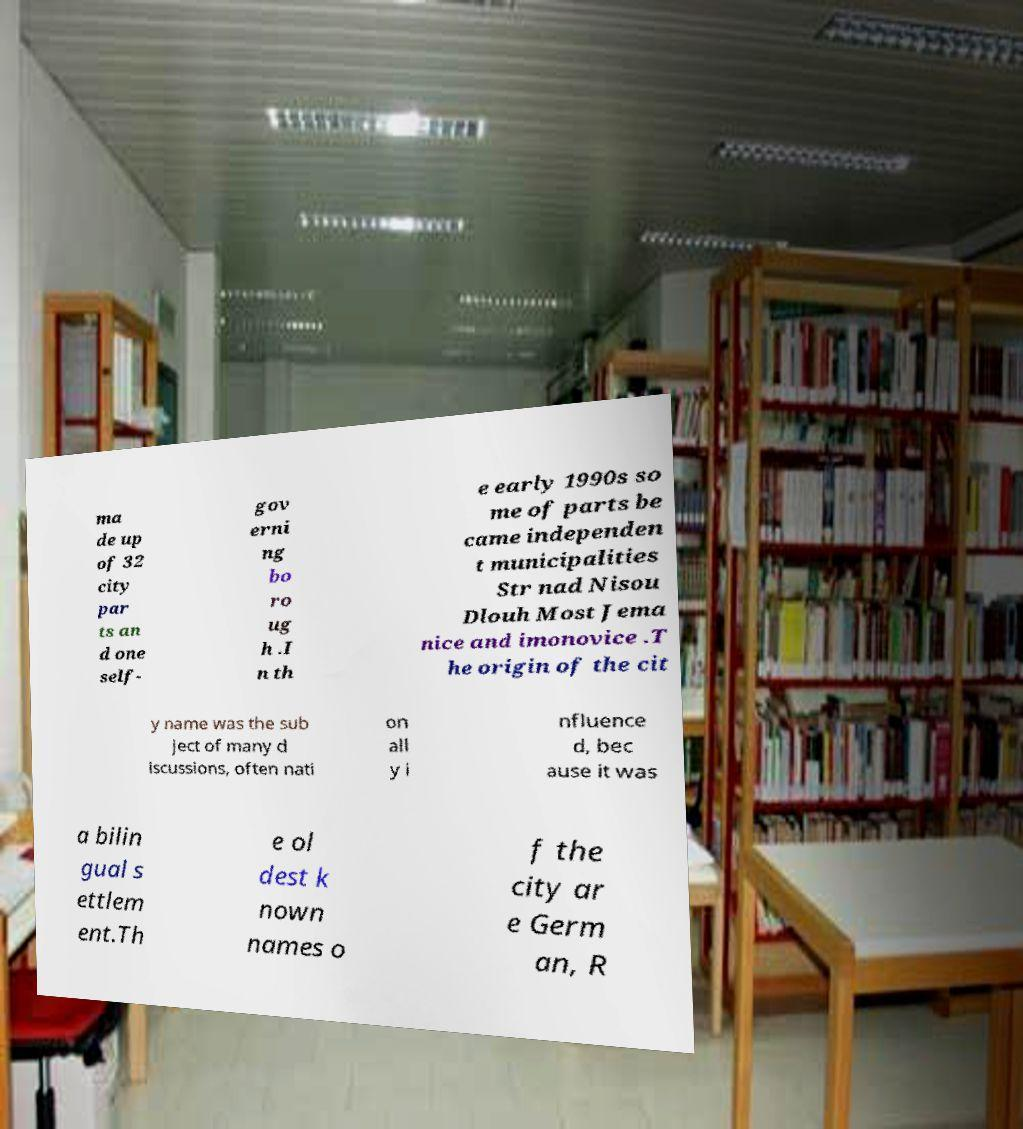Could you extract and type out the text from this image? ma de up of 32 city par ts an d one self- gov erni ng bo ro ug h .I n th e early 1990s so me of parts be came independen t municipalities Str nad Nisou Dlouh Most Jema nice and imonovice .T he origin of the cit y name was the sub ject of many d iscussions, often nati on all y i nfluence d, bec ause it was a bilin gual s ettlem ent.Th e ol dest k nown names o f the city ar e Germ an, R 